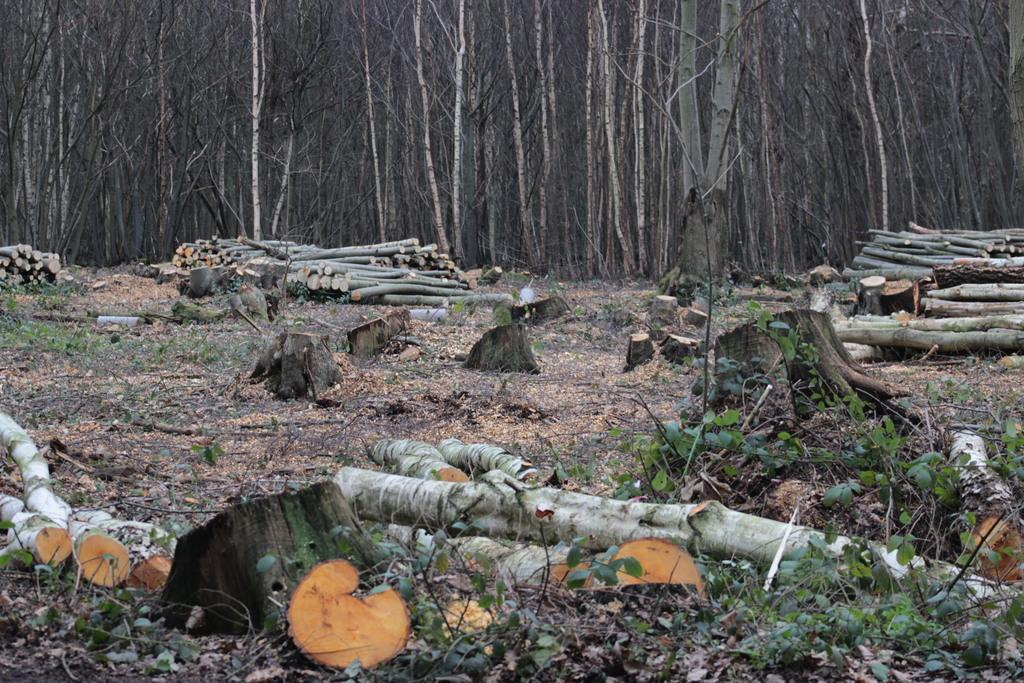What is the main subject in the center of the image? There are wood logs in the center of the image. What can be seen in the background of the image? There are trees in the background of the image. What type of vegetation is present at the bottom of the image? Some plants are present at the bottom of the image. What is visible at the bottom of the image? The ground is visible at the bottom of the image. What arithmetic problem is being solved by the trees in the image? There is no arithmetic problem being solved by the trees in the image; they are simply trees in the background. 